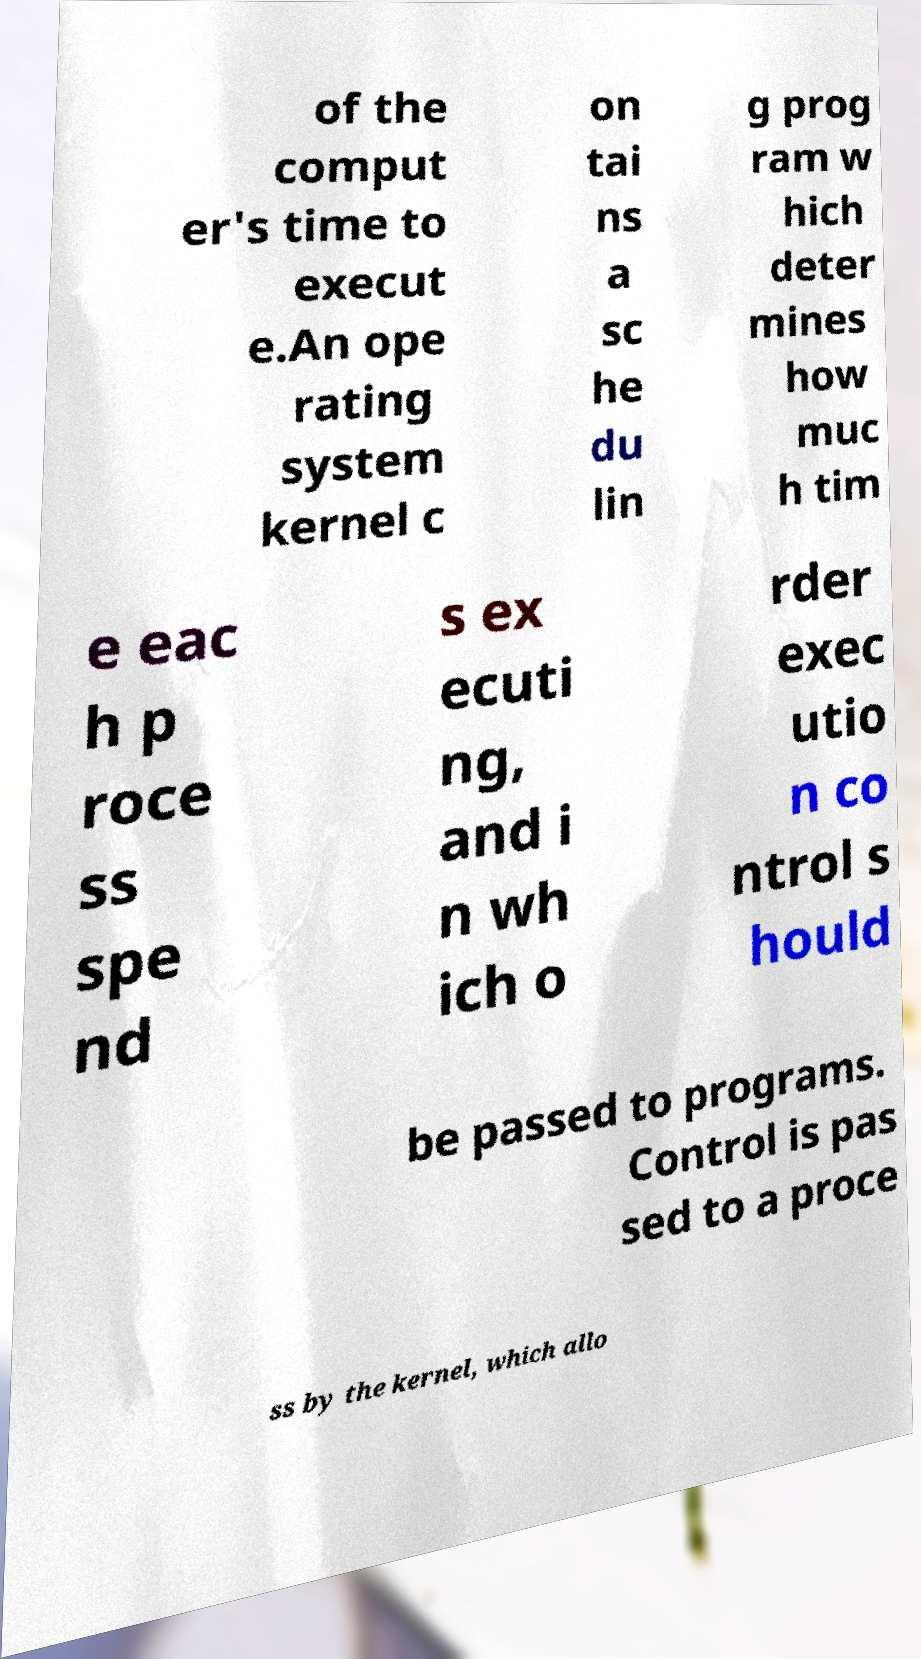Could you extract and type out the text from this image? of the comput er's time to execut e.An ope rating system kernel c on tai ns a sc he du lin g prog ram w hich deter mines how muc h tim e eac h p roce ss spe nd s ex ecuti ng, and i n wh ich o rder exec utio n co ntrol s hould be passed to programs. Control is pas sed to a proce ss by the kernel, which allo 